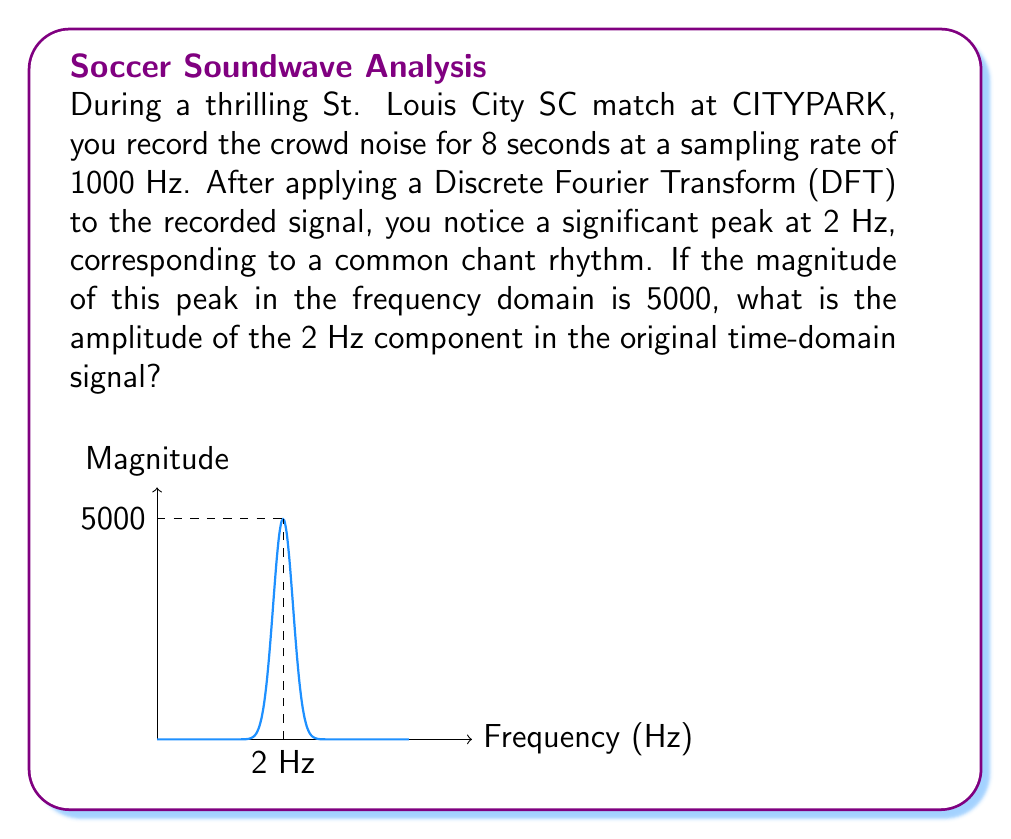Can you answer this question? Let's approach this step-by-step:

1) First, we need to understand the relationship between the DFT and the original signal. The DFT of a signal gives us the frequency components of that signal.

2) For a real-valued signal, the magnitude of a DFT coefficient at a particular frequency represents half of the peak-to-peak amplitude of the corresponding sinusoidal component in the time domain.

3) In this case, we're given that the magnitude of the DFT coefficient at 2 Hz is 5000.

4) To find the amplitude of the 2 Hz component in the time domain, we need to divide the magnitude by N/2, where N is the number of samples:

   $$ \text{Amplitude} = \frac{2 \cdot \text{Magnitude}}{N} $$

5) We can calculate N from the duration and sampling rate:
   $$ N = \text{Duration} \cdot \text{Sampling Rate} = 8 \text{ seconds} \cdot 1000 \text{ Hz} = 8000 \text{ samples} $$

6) Now we can calculate the amplitude:

   $$ \text{Amplitude} = \frac{2 \cdot 5000}{8000} = \frac{10000}{8000} = 1.25 $$

Therefore, the amplitude of the 2 Hz component in the original time-domain signal is 1.25.
Answer: 1.25 